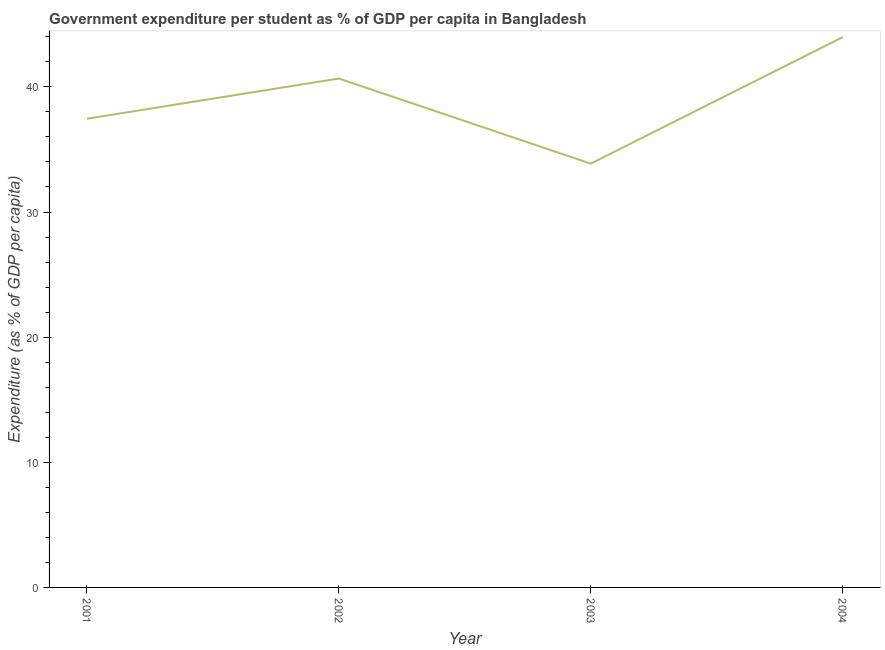What is the government expenditure per student in 2002?
Your response must be concise. 40.67. Across all years, what is the maximum government expenditure per student?
Offer a very short reply. 43.97. Across all years, what is the minimum government expenditure per student?
Offer a terse response. 33.87. What is the sum of the government expenditure per student?
Ensure brevity in your answer.  155.96. What is the difference between the government expenditure per student in 2001 and 2003?
Provide a succinct answer. 3.59. What is the average government expenditure per student per year?
Your answer should be very brief. 38.99. What is the median government expenditure per student?
Make the answer very short. 39.06. Do a majority of the years between 2004 and 2002 (inclusive) have government expenditure per student greater than 40 %?
Your answer should be compact. No. What is the ratio of the government expenditure per student in 2003 to that in 2004?
Provide a short and direct response. 0.77. Is the difference between the government expenditure per student in 2001 and 2002 greater than the difference between any two years?
Make the answer very short. No. What is the difference between the highest and the second highest government expenditure per student?
Keep it short and to the point. 3.31. What is the difference between the highest and the lowest government expenditure per student?
Your answer should be compact. 10.11. Does the government expenditure per student monotonically increase over the years?
Offer a very short reply. No. How many lines are there?
Provide a short and direct response. 1. How many years are there in the graph?
Offer a terse response. 4. What is the title of the graph?
Offer a terse response. Government expenditure per student as % of GDP per capita in Bangladesh. What is the label or title of the X-axis?
Provide a short and direct response. Year. What is the label or title of the Y-axis?
Offer a very short reply. Expenditure (as % of GDP per capita). What is the Expenditure (as % of GDP per capita) in 2001?
Provide a short and direct response. 37.45. What is the Expenditure (as % of GDP per capita) of 2002?
Your response must be concise. 40.67. What is the Expenditure (as % of GDP per capita) of 2003?
Provide a short and direct response. 33.87. What is the Expenditure (as % of GDP per capita) in 2004?
Offer a terse response. 43.97. What is the difference between the Expenditure (as % of GDP per capita) in 2001 and 2002?
Provide a succinct answer. -3.21. What is the difference between the Expenditure (as % of GDP per capita) in 2001 and 2003?
Keep it short and to the point. 3.59. What is the difference between the Expenditure (as % of GDP per capita) in 2001 and 2004?
Your answer should be very brief. -6.52. What is the difference between the Expenditure (as % of GDP per capita) in 2002 and 2003?
Give a very brief answer. 6.8. What is the difference between the Expenditure (as % of GDP per capita) in 2002 and 2004?
Offer a very short reply. -3.31. What is the difference between the Expenditure (as % of GDP per capita) in 2003 and 2004?
Your response must be concise. -10.11. What is the ratio of the Expenditure (as % of GDP per capita) in 2001 to that in 2002?
Your answer should be compact. 0.92. What is the ratio of the Expenditure (as % of GDP per capita) in 2001 to that in 2003?
Provide a short and direct response. 1.11. What is the ratio of the Expenditure (as % of GDP per capita) in 2001 to that in 2004?
Offer a terse response. 0.85. What is the ratio of the Expenditure (as % of GDP per capita) in 2002 to that in 2003?
Make the answer very short. 1.2. What is the ratio of the Expenditure (as % of GDP per capita) in 2002 to that in 2004?
Offer a very short reply. 0.93. What is the ratio of the Expenditure (as % of GDP per capita) in 2003 to that in 2004?
Your answer should be very brief. 0.77. 